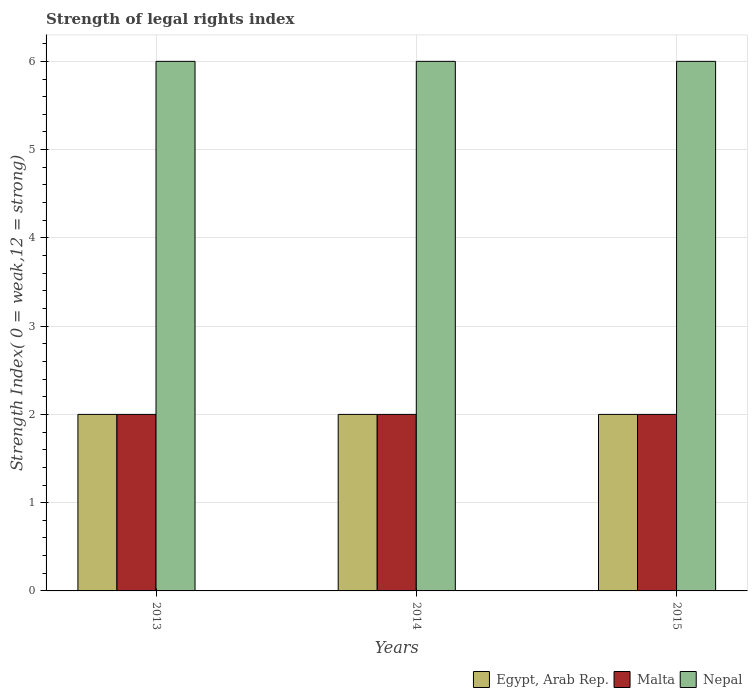How many different coloured bars are there?
Your response must be concise. 3. How many bars are there on the 2nd tick from the left?
Make the answer very short. 3. How many bars are there on the 3rd tick from the right?
Give a very brief answer. 3. What is the label of the 2nd group of bars from the left?
Make the answer very short. 2014. What is the strength index in Egypt, Arab Rep. in 2013?
Ensure brevity in your answer.  2. Across all years, what is the maximum strength index in Malta?
Your answer should be compact. 2. Across all years, what is the minimum strength index in Malta?
Your response must be concise. 2. What is the total strength index in Malta in the graph?
Give a very brief answer. 6. What is the difference between the strength index in Egypt, Arab Rep. in 2014 and that in 2015?
Offer a very short reply. 0. What is the average strength index in Egypt, Arab Rep. per year?
Provide a succinct answer. 2. In the year 2013, what is the difference between the strength index in Nepal and strength index in Egypt, Arab Rep.?
Provide a succinct answer. 4. What is the ratio of the strength index in Egypt, Arab Rep. in 2014 to that in 2015?
Make the answer very short. 1. What is the difference between the highest and the second highest strength index in Egypt, Arab Rep.?
Offer a terse response. 0. In how many years, is the strength index in Malta greater than the average strength index in Malta taken over all years?
Make the answer very short. 0. What does the 3rd bar from the left in 2014 represents?
Your answer should be compact. Nepal. What does the 2nd bar from the right in 2015 represents?
Give a very brief answer. Malta. How many bars are there?
Provide a succinct answer. 9. Are all the bars in the graph horizontal?
Offer a very short reply. No. How many years are there in the graph?
Offer a very short reply. 3. Are the values on the major ticks of Y-axis written in scientific E-notation?
Provide a succinct answer. No. Does the graph contain grids?
Your response must be concise. Yes. Where does the legend appear in the graph?
Give a very brief answer. Bottom right. How many legend labels are there?
Make the answer very short. 3. How are the legend labels stacked?
Provide a short and direct response. Horizontal. What is the title of the graph?
Your answer should be compact. Strength of legal rights index. What is the label or title of the Y-axis?
Provide a succinct answer. Strength Index( 0 = weak,12 = strong). What is the Strength Index( 0 = weak,12 = strong) in Egypt, Arab Rep. in 2013?
Your answer should be very brief. 2. What is the Strength Index( 0 = weak,12 = strong) in Nepal in 2013?
Offer a terse response. 6. What is the Strength Index( 0 = weak,12 = strong) in Malta in 2014?
Ensure brevity in your answer.  2. What is the Strength Index( 0 = weak,12 = strong) in Egypt, Arab Rep. in 2015?
Offer a very short reply. 2. What is the Strength Index( 0 = weak,12 = strong) of Malta in 2015?
Give a very brief answer. 2. What is the Strength Index( 0 = weak,12 = strong) in Nepal in 2015?
Keep it short and to the point. 6. Across all years, what is the maximum Strength Index( 0 = weak,12 = strong) of Malta?
Make the answer very short. 2. Across all years, what is the minimum Strength Index( 0 = weak,12 = strong) of Malta?
Give a very brief answer. 2. What is the difference between the Strength Index( 0 = weak,12 = strong) of Malta in 2013 and that in 2014?
Give a very brief answer. 0. What is the difference between the Strength Index( 0 = weak,12 = strong) in Nepal in 2013 and that in 2014?
Your answer should be very brief. 0. What is the difference between the Strength Index( 0 = weak,12 = strong) in Egypt, Arab Rep. in 2013 and that in 2015?
Your response must be concise. 0. What is the difference between the Strength Index( 0 = weak,12 = strong) in Malta in 2014 and that in 2015?
Your answer should be compact. 0. What is the difference between the Strength Index( 0 = weak,12 = strong) of Nepal in 2014 and that in 2015?
Ensure brevity in your answer.  0. What is the difference between the Strength Index( 0 = weak,12 = strong) of Egypt, Arab Rep. in 2013 and the Strength Index( 0 = weak,12 = strong) of Nepal in 2014?
Offer a very short reply. -4. What is the difference between the Strength Index( 0 = weak,12 = strong) in Egypt, Arab Rep. in 2013 and the Strength Index( 0 = weak,12 = strong) in Malta in 2015?
Your answer should be compact. 0. What is the difference between the Strength Index( 0 = weak,12 = strong) in Egypt, Arab Rep. in 2014 and the Strength Index( 0 = weak,12 = strong) in Nepal in 2015?
Your response must be concise. -4. What is the difference between the Strength Index( 0 = weak,12 = strong) of Malta in 2014 and the Strength Index( 0 = weak,12 = strong) of Nepal in 2015?
Keep it short and to the point. -4. In the year 2013, what is the difference between the Strength Index( 0 = weak,12 = strong) of Egypt, Arab Rep. and Strength Index( 0 = weak,12 = strong) of Malta?
Your answer should be compact. 0. In the year 2013, what is the difference between the Strength Index( 0 = weak,12 = strong) in Egypt, Arab Rep. and Strength Index( 0 = weak,12 = strong) in Nepal?
Offer a terse response. -4. In the year 2014, what is the difference between the Strength Index( 0 = weak,12 = strong) of Egypt, Arab Rep. and Strength Index( 0 = weak,12 = strong) of Malta?
Provide a short and direct response. 0. In the year 2014, what is the difference between the Strength Index( 0 = weak,12 = strong) in Egypt, Arab Rep. and Strength Index( 0 = weak,12 = strong) in Nepal?
Provide a short and direct response. -4. In the year 2014, what is the difference between the Strength Index( 0 = weak,12 = strong) of Malta and Strength Index( 0 = weak,12 = strong) of Nepal?
Your answer should be very brief. -4. In the year 2015, what is the difference between the Strength Index( 0 = weak,12 = strong) of Egypt, Arab Rep. and Strength Index( 0 = weak,12 = strong) of Malta?
Your answer should be compact. 0. In the year 2015, what is the difference between the Strength Index( 0 = weak,12 = strong) of Egypt, Arab Rep. and Strength Index( 0 = weak,12 = strong) of Nepal?
Offer a very short reply. -4. In the year 2015, what is the difference between the Strength Index( 0 = weak,12 = strong) of Malta and Strength Index( 0 = weak,12 = strong) of Nepal?
Your answer should be compact. -4. What is the ratio of the Strength Index( 0 = weak,12 = strong) of Egypt, Arab Rep. in 2013 to that in 2014?
Give a very brief answer. 1. What is the ratio of the Strength Index( 0 = weak,12 = strong) in Malta in 2013 to that in 2014?
Your answer should be compact. 1. What is the ratio of the Strength Index( 0 = weak,12 = strong) in Nepal in 2013 to that in 2015?
Offer a terse response. 1. What is the ratio of the Strength Index( 0 = weak,12 = strong) of Nepal in 2014 to that in 2015?
Your answer should be compact. 1. What is the difference between the highest and the second highest Strength Index( 0 = weak,12 = strong) of Egypt, Arab Rep.?
Your response must be concise. 0. What is the difference between the highest and the second highest Strength Index( 0 = weak,12 = strong) of Malta?
Ensure brevity in your answer.  0. What is the difference between the highest and the second highest Strength Index( 0 = weak,12 = strong) in Nepal?
Keep it short and to the point. 0. 